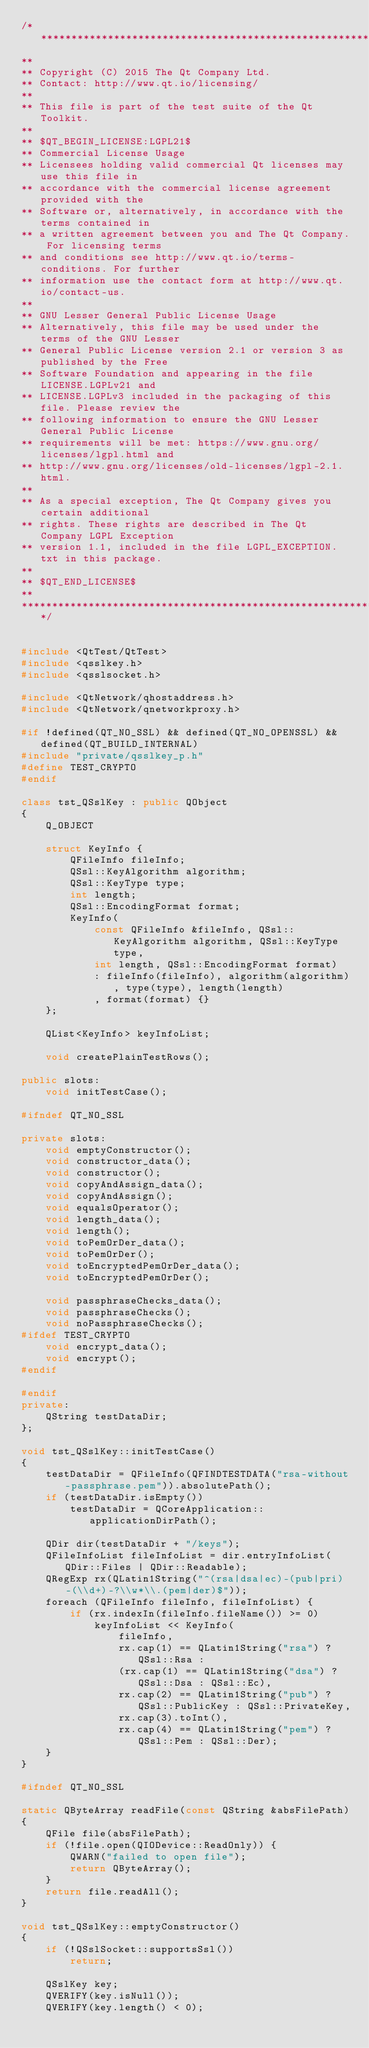<code> <loc_0><loc_0><loc_500><loc_500><_C++_>/****************************************************************************
**
** Copyright (C) 2015 The Qt Company Ltd.
** Contact: http://www.qt.io/licensing/
**
** This file is part of the test suite of the Qt Toolkit.
**
** $QT_BEGIN_LICENSE:LGPL21$
** Commercial License Usage
** Licensees holding valid commercial Qt licenses may use this file in
** accordance with the commercial license agreement provided with the
** Software or, alternatively, in accordance with the terms contained in
** a written agreement between you and The Qt Company. For licensing terms
** and conditions see http://www.qt.io/terms-conditions. For further
** information use the contact form at http://www.qt.io/contact-us.
**
** GNU Lesser General Public License Usage
** Alternatively, this file may be used under the terms of the GNU Lesser
** General Public License version 2.1 or version 3 as published by the Free
** Software Foundation and appearing in the file LICENSE.LGPLv21 and
** LICENSE.LGPLv3 included in the packaging of this file. Please review the
** following information to ensure the GNU Lesser General Public License
** requirements will be met: https://www.gnu.org/licenses/lgpl.html and
** http://www.gnu.org/licenses/old-licenses/lgpl-2.1.html.
**
** As a special exception, The Qt Company gives you certain additional
** rights. These rights are described in The Qt Company LGPL Exception
** version 1.1, included in the file LGPL_EXCEPTION.txt in this package.
**
** $QT_END_LICENSE$
**
****************************************************************************/


#include <QtTest/QtTest>
#include <qsslkey.h>
#include <qsslsocket.h>

#include <QtNetwork/qhostaddress.h>
#include <QtNetwork/qnetworkproxy.h>

#if !defined(QT_NO_SSL) && defined(QT_NO_OPENSSL) && defined(QT_BUILD_INTERNAL)
#include "private/qsslkey_p.h"
#define TEST_CRYPTO
#endif

class tst_QSslKey : public QObject
{
    Q_OBJECT

    struct KeyInfo {
        QFileInfo fileInfo;
        QSsl::KeyAlgorithm algorithm;
        QSsl::KeyType type;
        int length;
        QSsl::EncodingFormat format;
        KeyInfo(
            const QFileInfo &fileInfo, QSsl::KeyAlgorithm algorithm, QSsl::KeyType type,
            int length, QSsl::EncodingFormat format)
            : fileInfo(fileInfo), algorithm(algorithm), type(type), length(length)
            , format(format) {}
    };

    QList<KeyInfo> keyInfoList;

    void createPlainTestRows();

public slots:
    void initTestCase();

#ifndef QT_NO_SSL

private slots:
    void emptyConstructor();
    void constructor_data();
    void constructor();
    void copyAndAssign_data();
    void copyAndAssign();
    void equalsOperator();
    void length_data();
    void length();
    void toPemOrDer_data();
    void toPemOrDer();
    void toEncryptedPemOrDer_data();
    void toEncryptedPemOrDer();

    void passphraseChecks_data();
    void passphraseChecks();
    void noPassphraseChecks();
#ifdef TEST_CRYPTO
    void encrypt_data();
    void encrypt();
#endif

#endif
private:
    QString testDataDir;
};

void tst_QSslKey::initTestCase()
{
    testDataDir = QFileInfo(QFINDTESTDATA("rsa-without-passphrase.pem")).absolutePath();
    if (testDataDir.isEmpty())
        testDataDir = QCoreApplication::applicationDirPath();

    QDir dir(testDataDir + "/keys");
    QFileInfoList fileInfoList = dir.entryInfoList(QDir::Files | QDir::Readable);
    QRegExp rx(QLatin1String("^(rsa|dsa|ec)-(pub|pri)-(\\d+)-?\\w*\\.(pem|der)$"));
    foreach (QFileInfo fileInfo, fileInfoList) {
        if (rx.indexIn(fileInfo.fileName()) >= 0)
            keyInfoList << KeyInfo(
                fileInfo,
                rx.cap(1) == QLatin1String("rsa") ? QSsl::Rsa :
                (rx.cap(1) == QLatin1String("dsa") ? QSsl::Dsa : QSsl::Ec),
                rx.cap(2) == QLatin1String("pub") ? QSsl::PublicKey : QSsl::PrivateKey,
                rx.cap(3).toInt(),
                rx.cap(4) == QLatin1String("pem") ? QSsl::Pem : QSsl::Der);
    }
}

#ifndef QT_NO_SSL

static QByteArray readFile(const QString &absFilePath)
{
    QFile file(absFilePath);
    if (!file.open(QIODevice::ReadOnly)) {
        QWARN("failed to open file");
        return QByteArray();
    }
    return file.readAll();
}

void tst_QSslKey::emptyConstructor()
{
    if (!QSslSocket::supportsSsl())
        return;

    QSslKey key;
    QVERIFY(key.isNull());
    QVERIFY(key.length() < 0);
</code> 